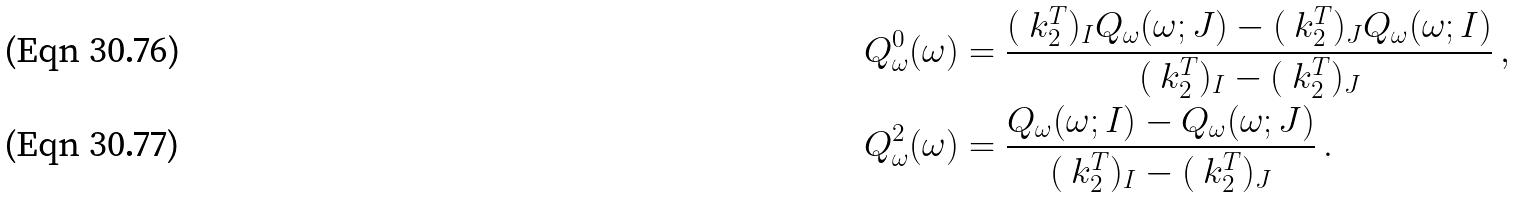Convert formula to latex. <formula><loc_0><loc_0><loc_500><loc_500>Q _ { \omega } ^ { 0 } ( \omega ) & = \frac { ( \ k _ { 2 } ^ { T } ) _ { I } Q _ { \omega } ( \omega ; J ) - ( \ k _ { 2 } ^ { T } ) _ { J } Q _ { \omega } ( \omega ; I ) } { ( \ k _ { 2 } ^ { T } ) _ { I } - ( \ k _ { 2 } ^ { T } ) _ { J } } \, , \\ Q _ { \omega } ^ { 2 } ( \omega ) & = \frac { Q _ { \omega } ( \omega ; I ) - Q _ { \omega } ( \omega ; J ) } { ( \ k _ { 2 } ^ { T } ) _ { I } - ( \ k _ { 2 } ^ { T } ) _ { J } } \, .</formula> 